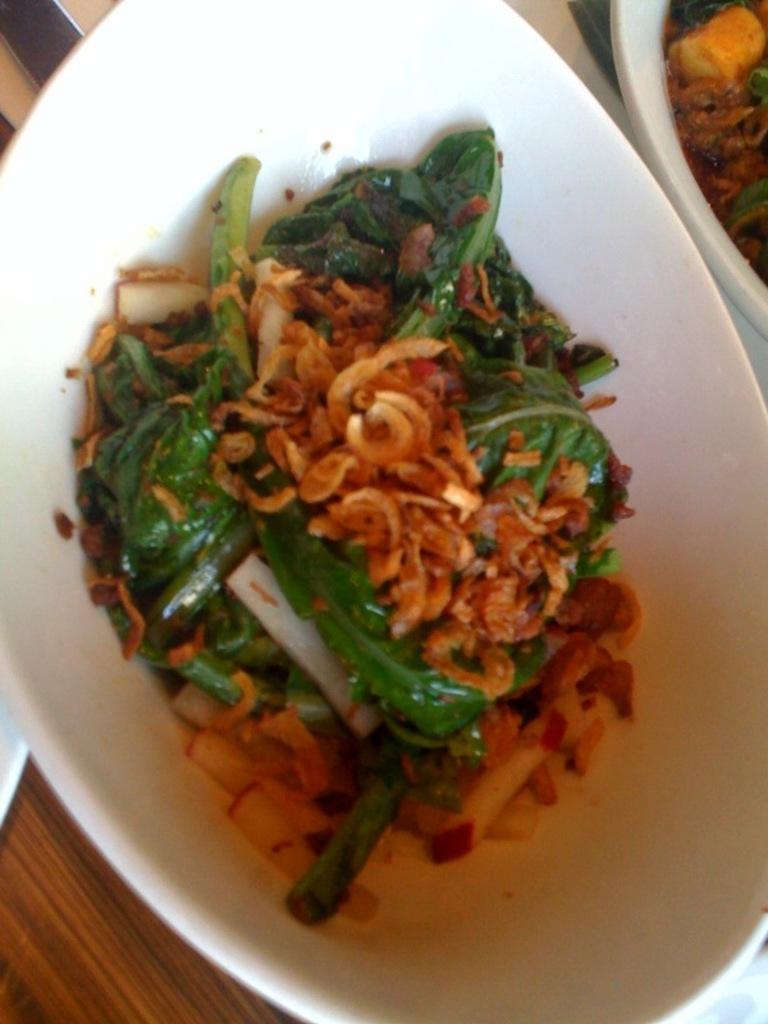How would you summarize this image in a sentence or two? In this image, we can see a white color bowl and there is some food in the bowl. 